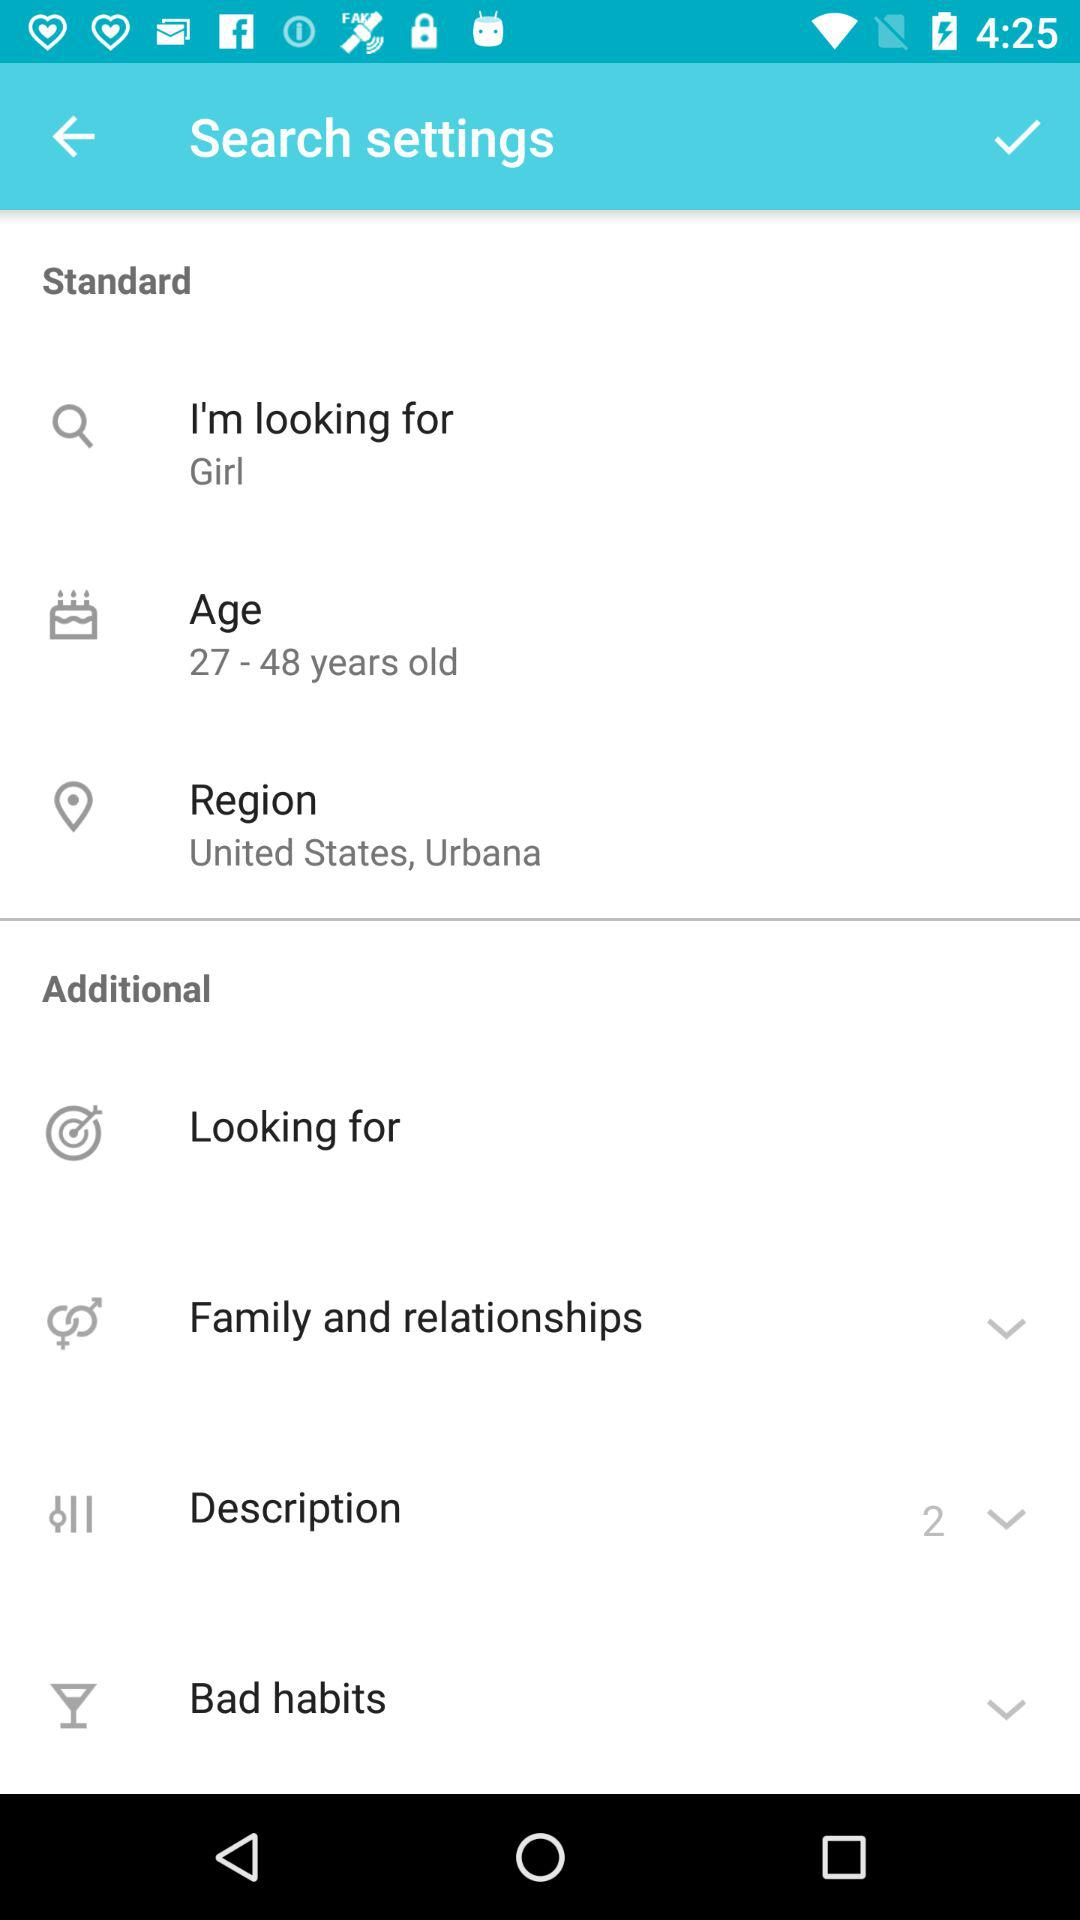What is the age range? The age range is from 27 to 48 years old. 